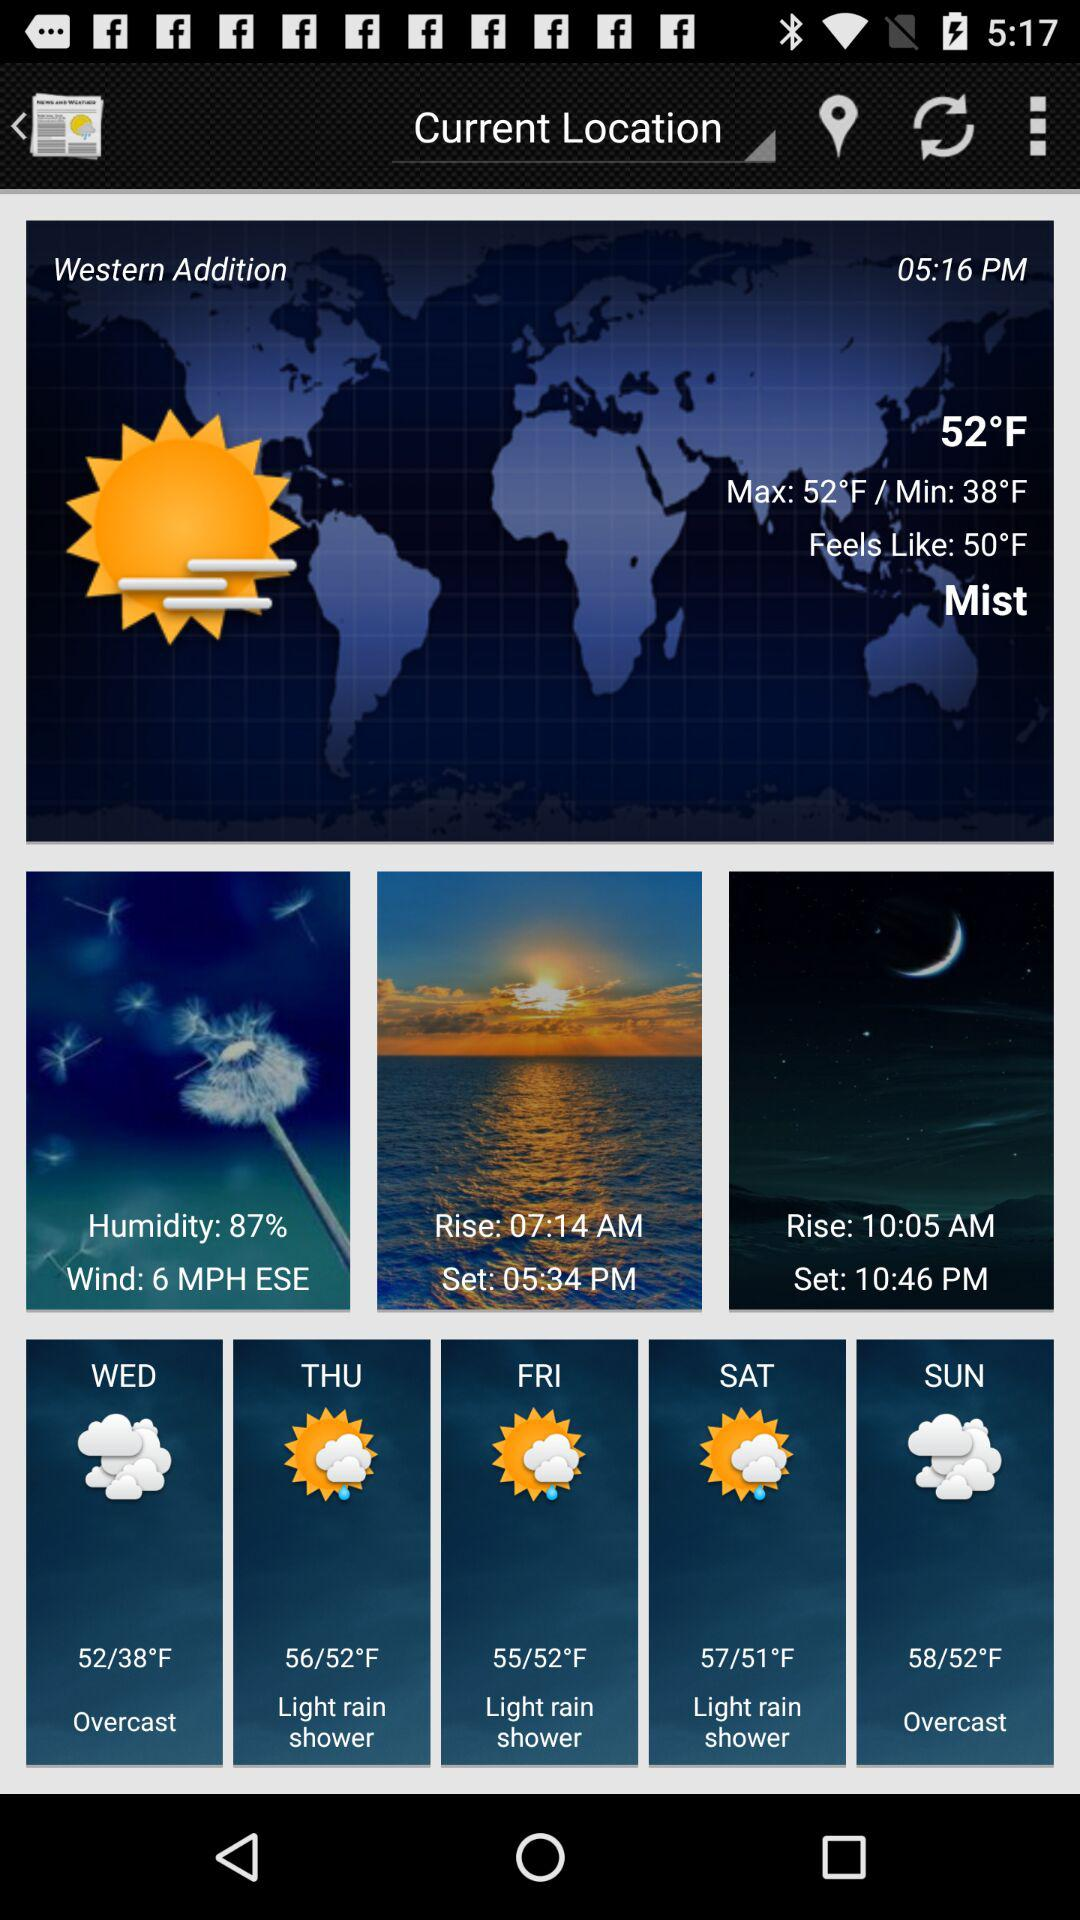What is the maximum temperature? The maximum temperature is 52 °F. 